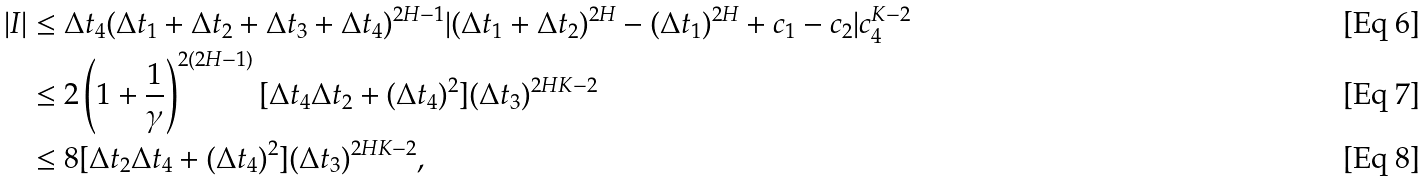<formula> <loc_0><loc_0><loc_500><loc_500>| I | & \leq \Delta t _ { 4 } ( \Delta t _ { 1 } + \Delta t _ { 2 } + \Delta t _ { 3 } + \Delta t _ { 4 } ) ^ { 2 H - 1 } | ( \Delta t _ { 1 } + \Delta t _ { 2 } ) ^ { 2 H } - ( \Delta t _ { 1 } ) ^ { 2 H } + c _ { 1 } - c _ { 2 } | c _ { 4 } ^ { K - 2 } \\ & \leq 2 \left ( 1 + \frac { 1 } { \gamma } \right ) ^ { 2 ( 2 H - 1 ) } [ \Delta t _ { 4 } \Delta t _ { 2 } + ( \Delta t _ { 4 } ) ^ { 2 } ] ( \Delta t _ { 3 } ) ^ { 2 H K - 2 } \\ & \leq 8 [ \Delta t _ { 2 } \Delta t _ { 4 } + ( \Delta t _ { 4 } ) ^ { 2 } ] ( \Delta t _ { 3 } ) ^ { 2 H K - 2 } ,</formula> 